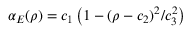Convert formula to latex. <formula><loc_0><loc_0><loc_500><loc_500>\alpha _ { E } ( \rho ) = c _ { 1 } \left ( 1 - ( \rho - c _ { 2 } ) ^ { 2 } / c _ { 3 } ^ { 2 } \right )</formula> 